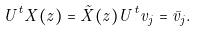Convert formula to latex. <formula><loc_0><loc_0><loc_500><loc_500>U ^ { t } X ( z ) = \tilde { X } ( z ) U ^ { t } v _ { j } = \bar { v } _ { j } .</formula> 